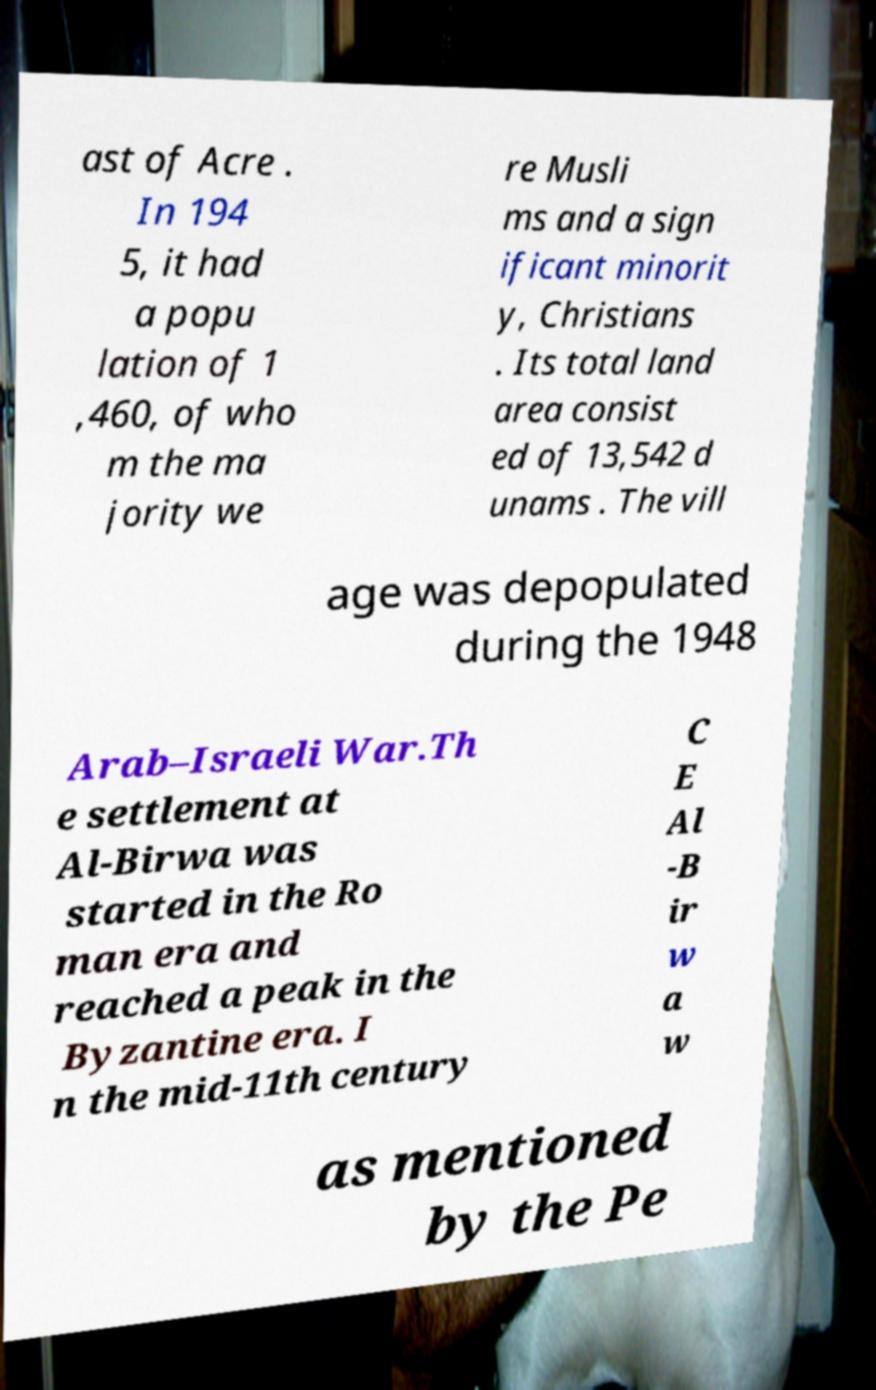There's text embedded in this image that I need extracted. Can you transcribe it verbatim? ast of Acre . In 194 5, it had a popu lation of 1 ,460, of who m the ma jority we re Musli ms and a sign ificant minorit y, Christians . Its total land area consist ed of 13,542 d unams . The vill age was depopulated during the 1948 Arab–Israeli War.Th e settlement at Al-Birwa was started in the Ro man era and reached a peak in the Byzantine era. I n the mid-11th century C E Al -B ir w a w as mentioned by the Pe 